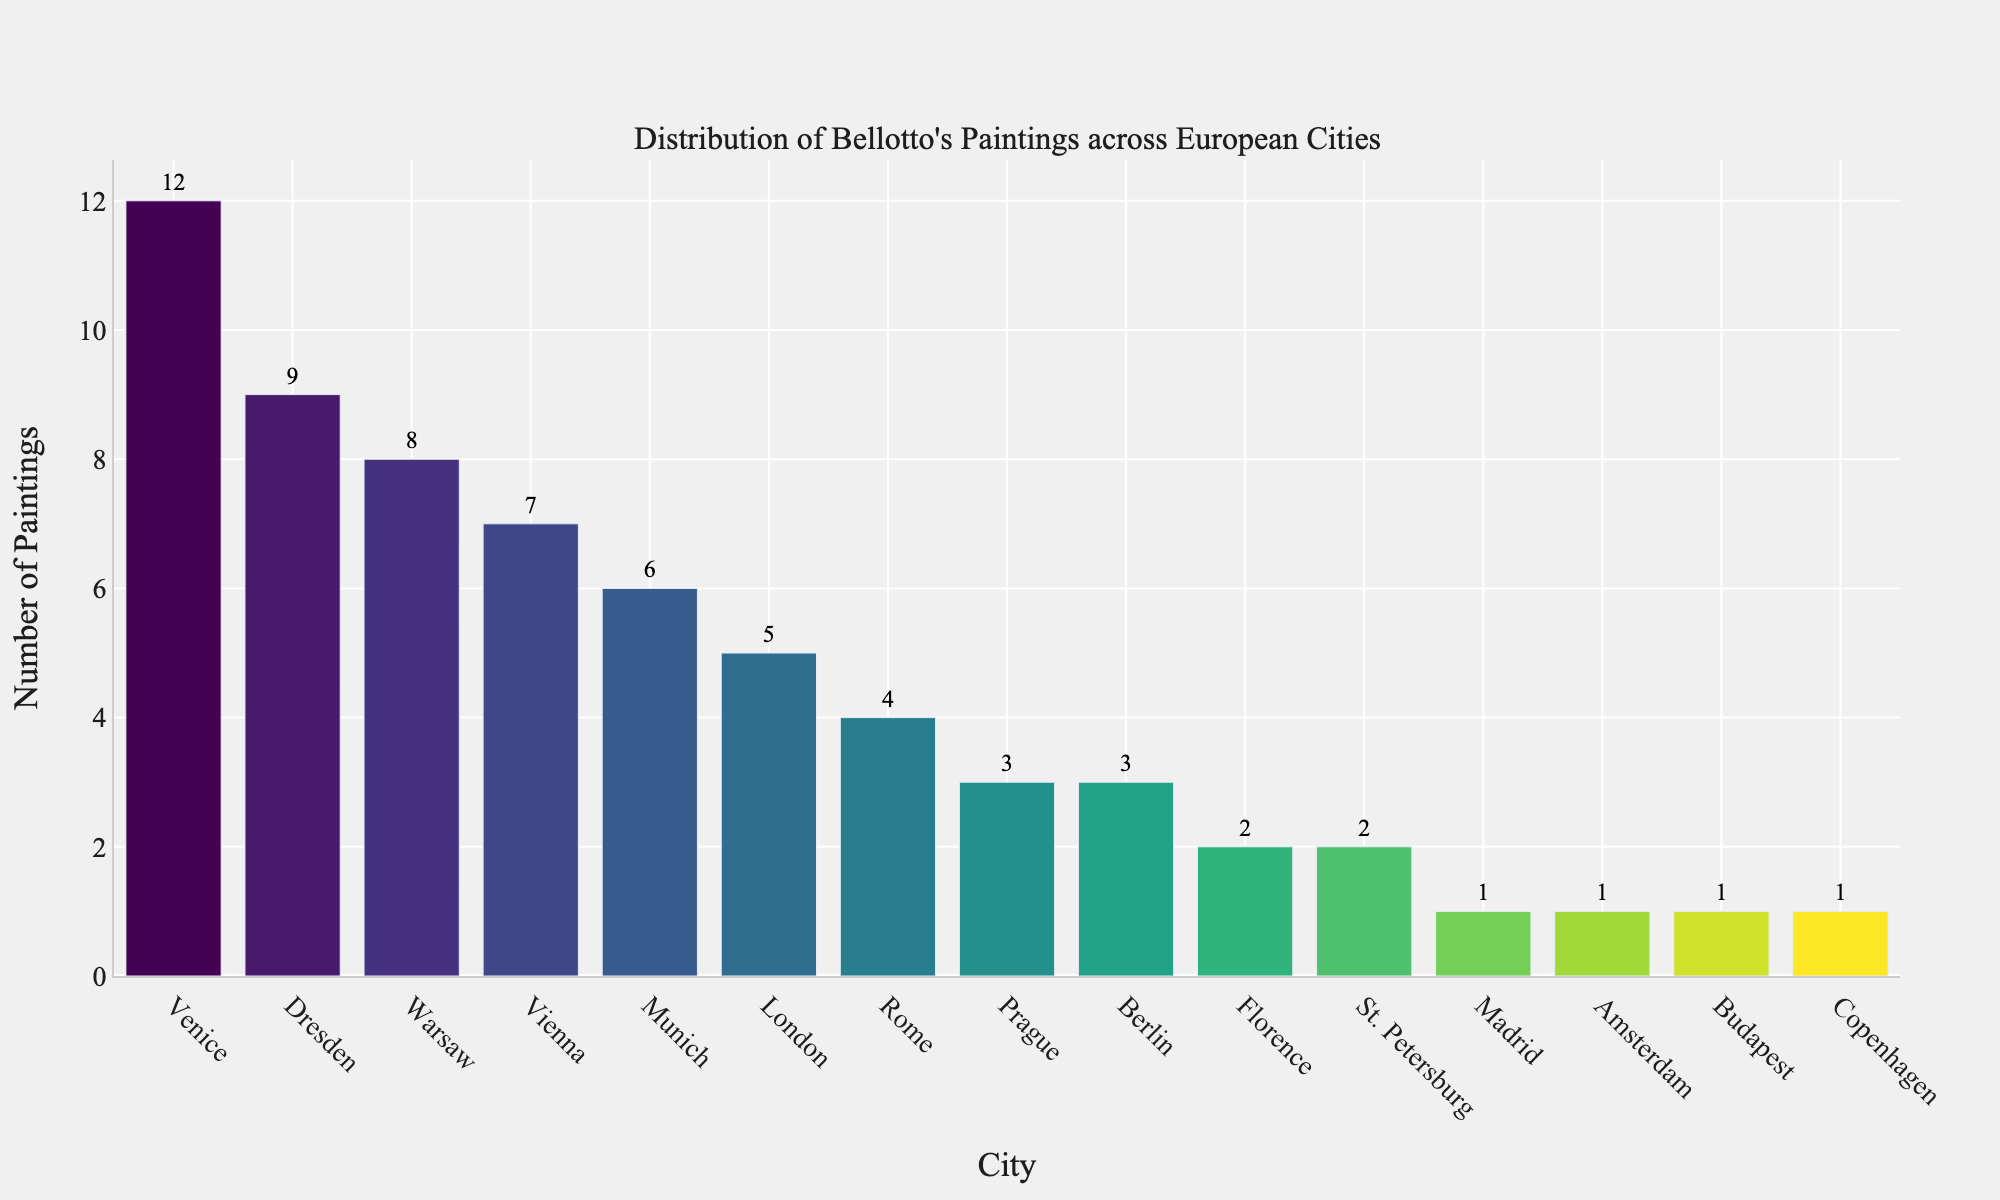what are the three cities with the most Bellotto's paintings? First, identify the cities by looking at the labels on the x-axis, then observe the height of the bars representing each city. The tallest bars indicate the cities with the most paintings.
Answer: Venice, Dresden, Warsaw which city has the fewest Bellotto's paintings? Look for the shortest bar on the chart and read the city label directly below it. This bar represents the city with the fewest paintings.
Answer: Madrid, Amsterdam, Budapest, Copenhagen how many total paintings are in the top five cities? Identify the top five cities by noting the five tallest bars: Venice, Dresden, Warsaw, Vienna, and Munich. Add the number of paintings for these cities from the y-axis values: 12 (Venice) + 9 (Dresden) + 8 (Warsaw) + 7 (Vienna) + 6 (Munich) = 42.
Answer: 42 which city has exactly half the number of paintings compared to Venice? Venice has 12 paintings. Half of 12 is 6. Look for the bar with a height corresponding to 6 paintings on the y-axis, which represents Munich.
Answer: Munich which city has more paintings, Prague or Berlin? Compare the height of the bars representing Prague and Berlin. Prague’s bar is slightly higher than Berlin's, meaning it has more paintings.
Answer: Prague how many cities have more than 5 paintings? Count the number of bars that have a height greater than the value of 5 on the y-axis. These are Venice, Dresden, Warsaw, Vienna, and Munich, a total of 5 cities.
Answer: 5 what is the difference in the number of paintings between Rome and St. Petersburg? Find the height of the bars for Rome and St. Petersburg. Rome has 4 paintings, and St. Petersburg has 2 paintings. The difference is 4 - 2 = 2.
Answer: 2 which cities have the same number of paintings? Compare the heights of the bars and pairs that have the same height. Berlin and Prague both have 3 paintings each. Florence and St. Petersburg both have 2 paintings each.
Answer: Berlin and Prague; Florence and St. Petersburg 